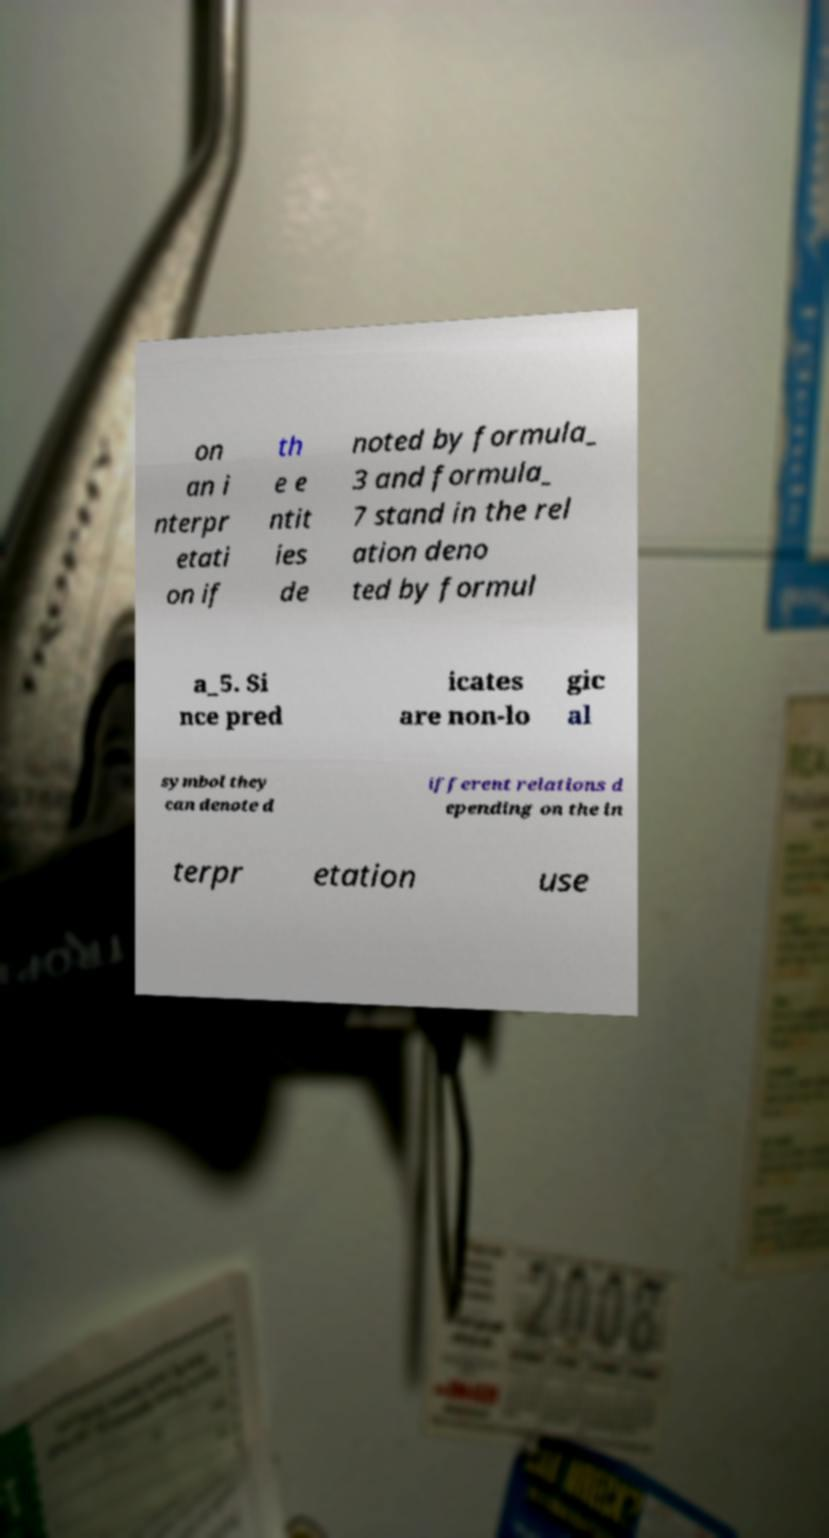Please identify and transcribe the text found in this image. on an i nterpr etati on if th e e ntit ies de noted by formula_ 3 and formula_ 7 stand in the rel ation deno ted by formul a_5. Si nce pred icates are non-lo gic al symbol they can denote d ifferent relations d epending on the in terpr etation use 